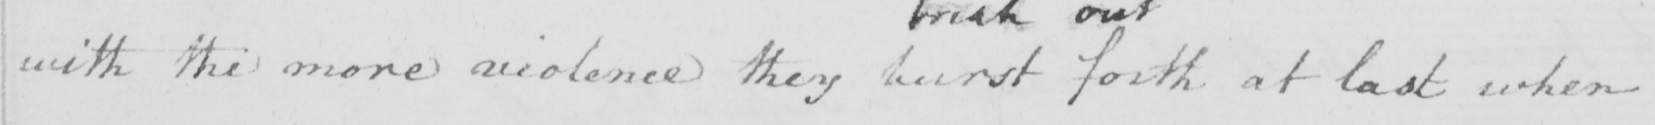Please transcribe the handwritten text in this image. with the more violence they burst forth at last when 